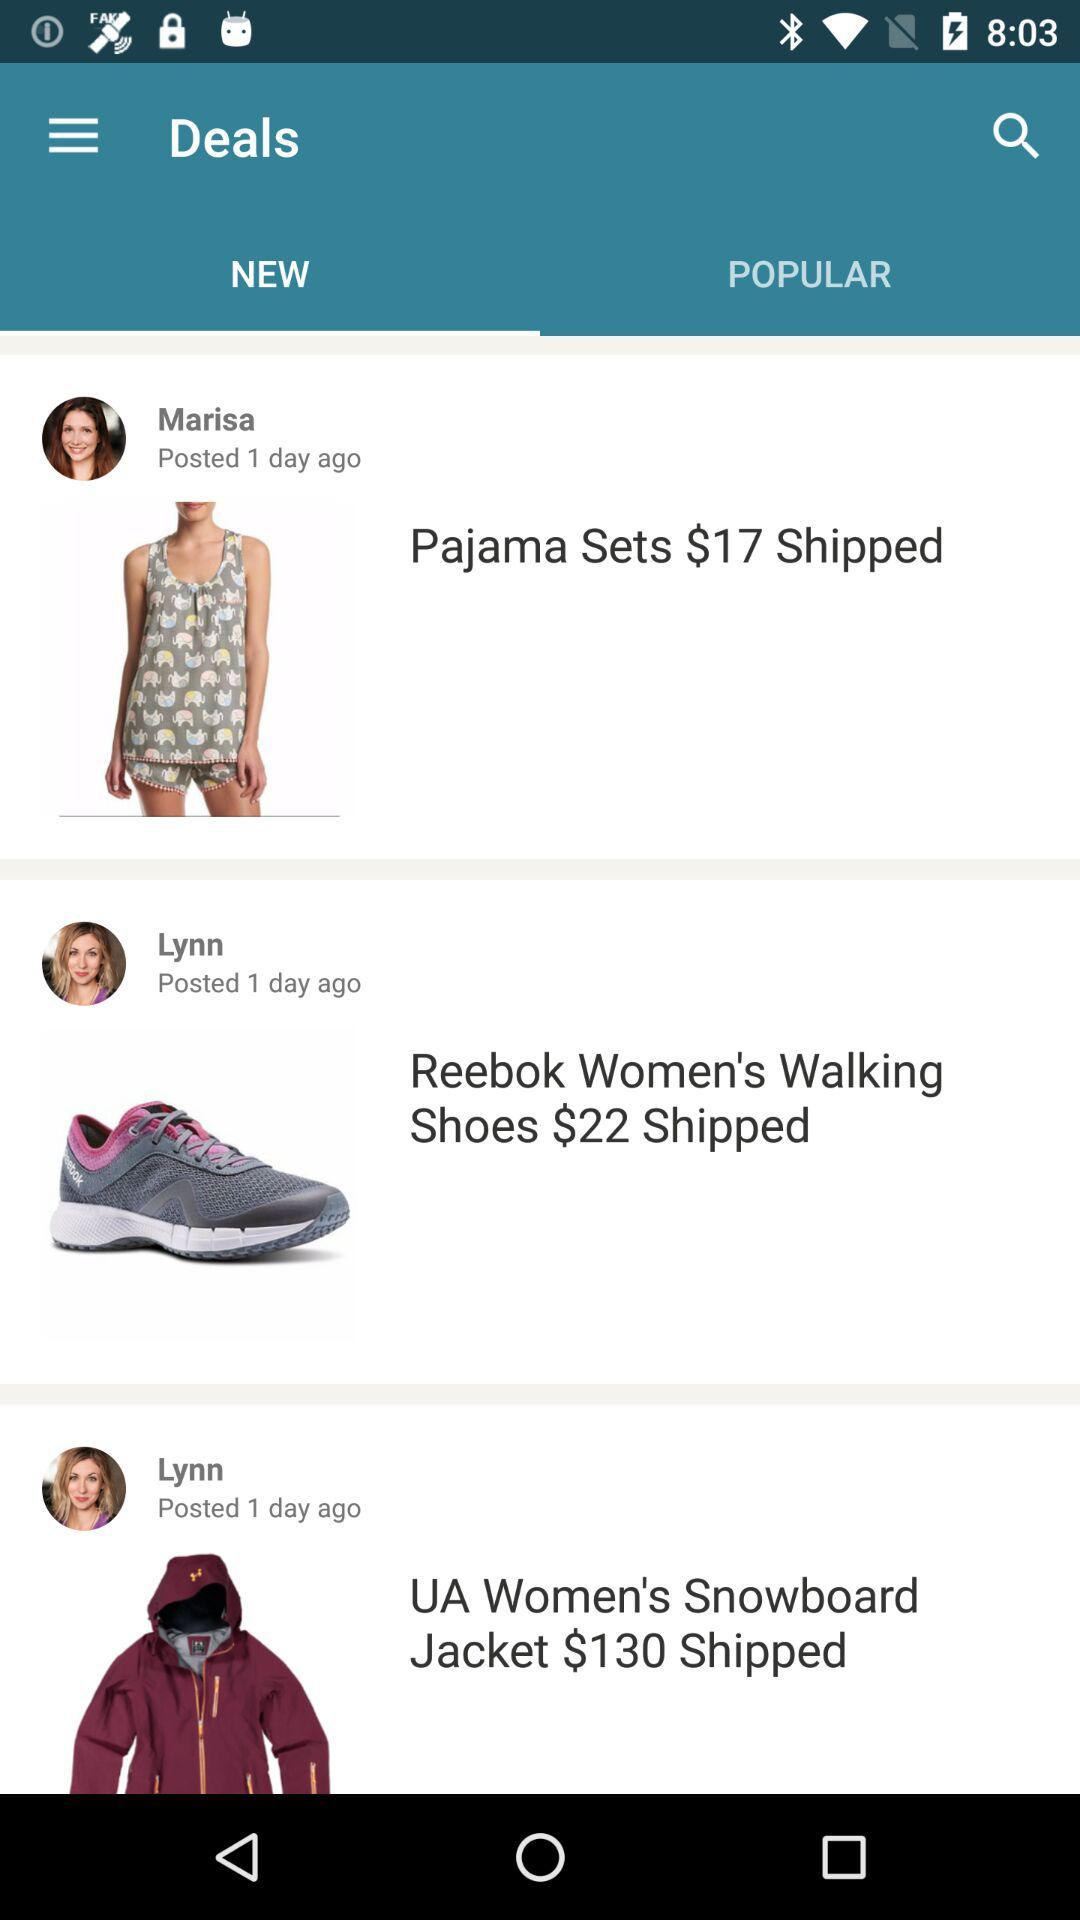How many items are from Lynn?
Answer the question using a single word or phrase. 2 